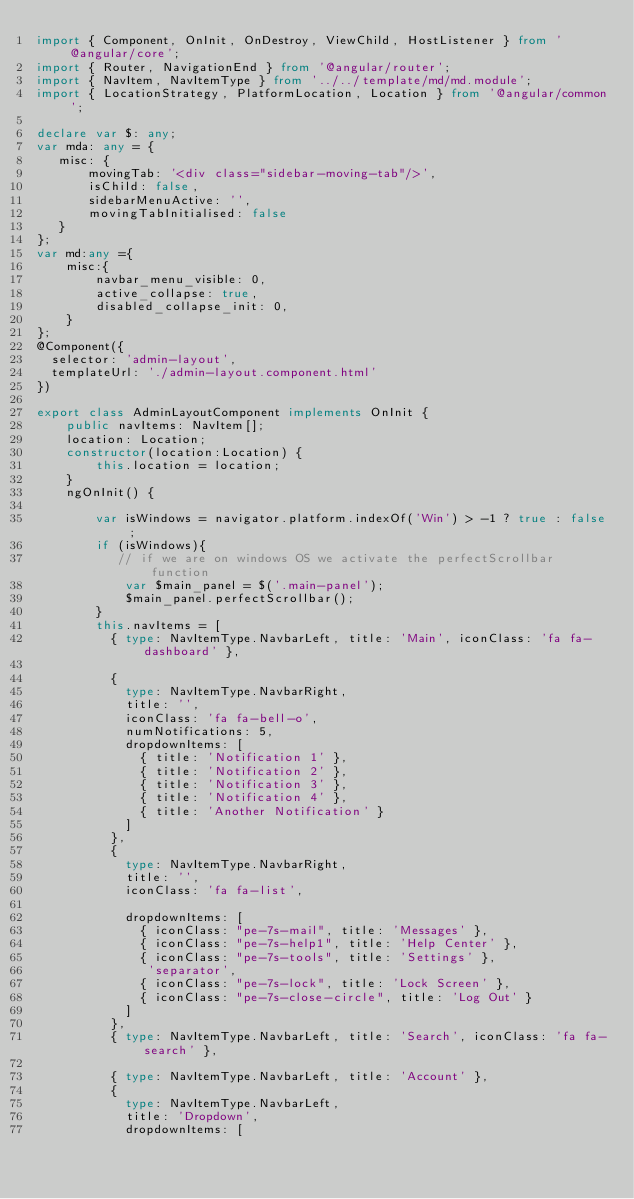<code> <loc_0><loc_0><loc_500><loc_500><_TypeScript_>import { Component, OnInit, OnDestroy, ViewChild, HostListener } from '@angular/core';
import { Router, NavigationEnd } from '@angular/router';
import { NavItem, NavItemType } from '../../template/md/md.module';
import { LocationStrategy, PlatformLocation, Location } from '@angular/common';

declare var $: any;
var mda: any = {
   misc: {
       movingTab: '<div class="sidebar-moving-tab"/>',
       isChild: false,
       sidebarMenuActive: '',
       movingTabInitialised: false
   }
};
var md:any ={
    misc:{
        navbar_menu_visible: 0,
        active_collapse: true,
        disabled_collapse_init: 0,
    }
};
@Component({
  selector: 'admin-layout',
  templateUrl: './admin-layout.component.html'
})

export class AdminLayoutComponent implements OnInit {
    public navItems: NavItem[];
    location: Location;
    constructor(location:Location) {
        this.location = location;
    }
    ngOnInit() {

        var isWindows = navigator.platform.indexOf('Win') > -1 ? true : false;
        if (isWindows){
           // if we are on windows OS we activate the perfectScrollbar function
            var $main_panel = $('.main-panel');
            $main_panel.perfectScrollbar();
        }
        this.navItems = [
          { type: NavItemType.NavbarLeft, title: 'Main', iconClass: 'fa fa-dashboard' },

          {
            type: NavItemType.NavbarRight,
            title: '',
            iconClass: 'fa fa-bell-o',
            numNotifications: 5,
            dropdownItems: [
              { title: 'Notification 1' },
              { title: 'Notification 2' },
              { title: 'Notification 3' },
              { title: 'Notification 4' },
              { title: 'Another Notification' }
            ]
          },
          {
            type: NavItemType.NavbarRight,
            title: '',
            iconClass: 'fa fa-list',

            dropdownItems: [
              { iconClass: "pe-7s-mail", title: 'Messages' },
              { iconClass: "pe-7s-help1", title: 'Help Center' },
              { iconClass: "pe-7s-tools", title: 'Settings' },
               'separator',
              { iconClass: "pe-7s-lock", title: 'Lock Screen' },
              { iconClass: "pe-7s-close-circle", title: 'Log Out' }
            ]
          },
          { type: NavItemType.NavbarLeft, title: 'Search', iconClass: 'fa fa-search' },

          { type: NavItemType.NavbarLeft, title: 'Account' },
          {
            type: NavItemType.NavbarLeft,
            title: 'Dropdown',
            dropdownItems: [</code> 